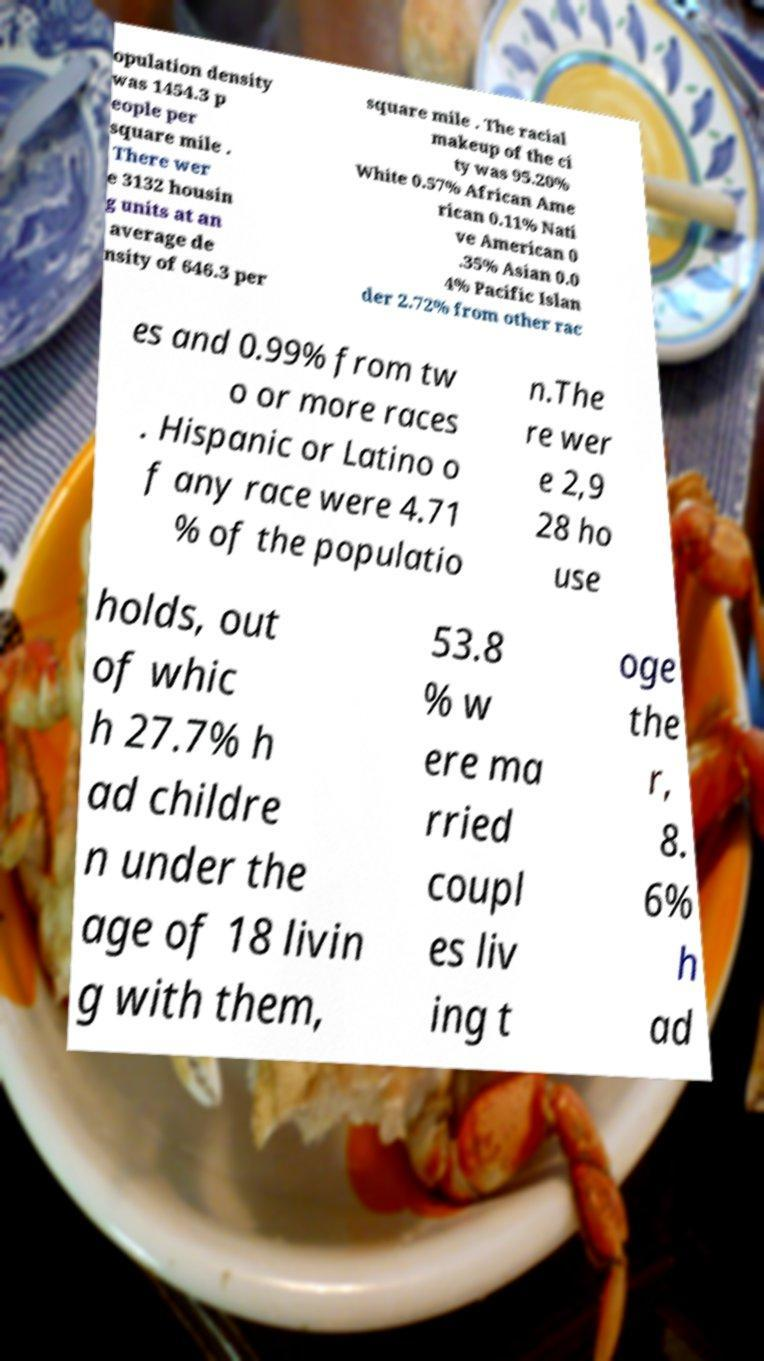Please read and relay the text visible in this image. What does it say? opulation density was 1454.3 p eople per square mile . There wer e 3132 housin g units at an average de nsity of 646.3 per square mile . The racial makeup of the ci ty was 95.20% White 0.57% African Ame rican 0.11% Nati ve American 0 .35% Asian 0.0 4% Pacific Islan der 2.72% from other rac es and 0.99% from tw o or more races . Hispanic or Latino o f any race were 4.71 % of the populatio n.The re wer e 2,9 28 ho use holds, out of whic h 27.7% h ad childre n under the age of 18 livin g with them, 53.8 % w ere ma rried coupl es liv ing t oge the r, 8. 6% h ad 